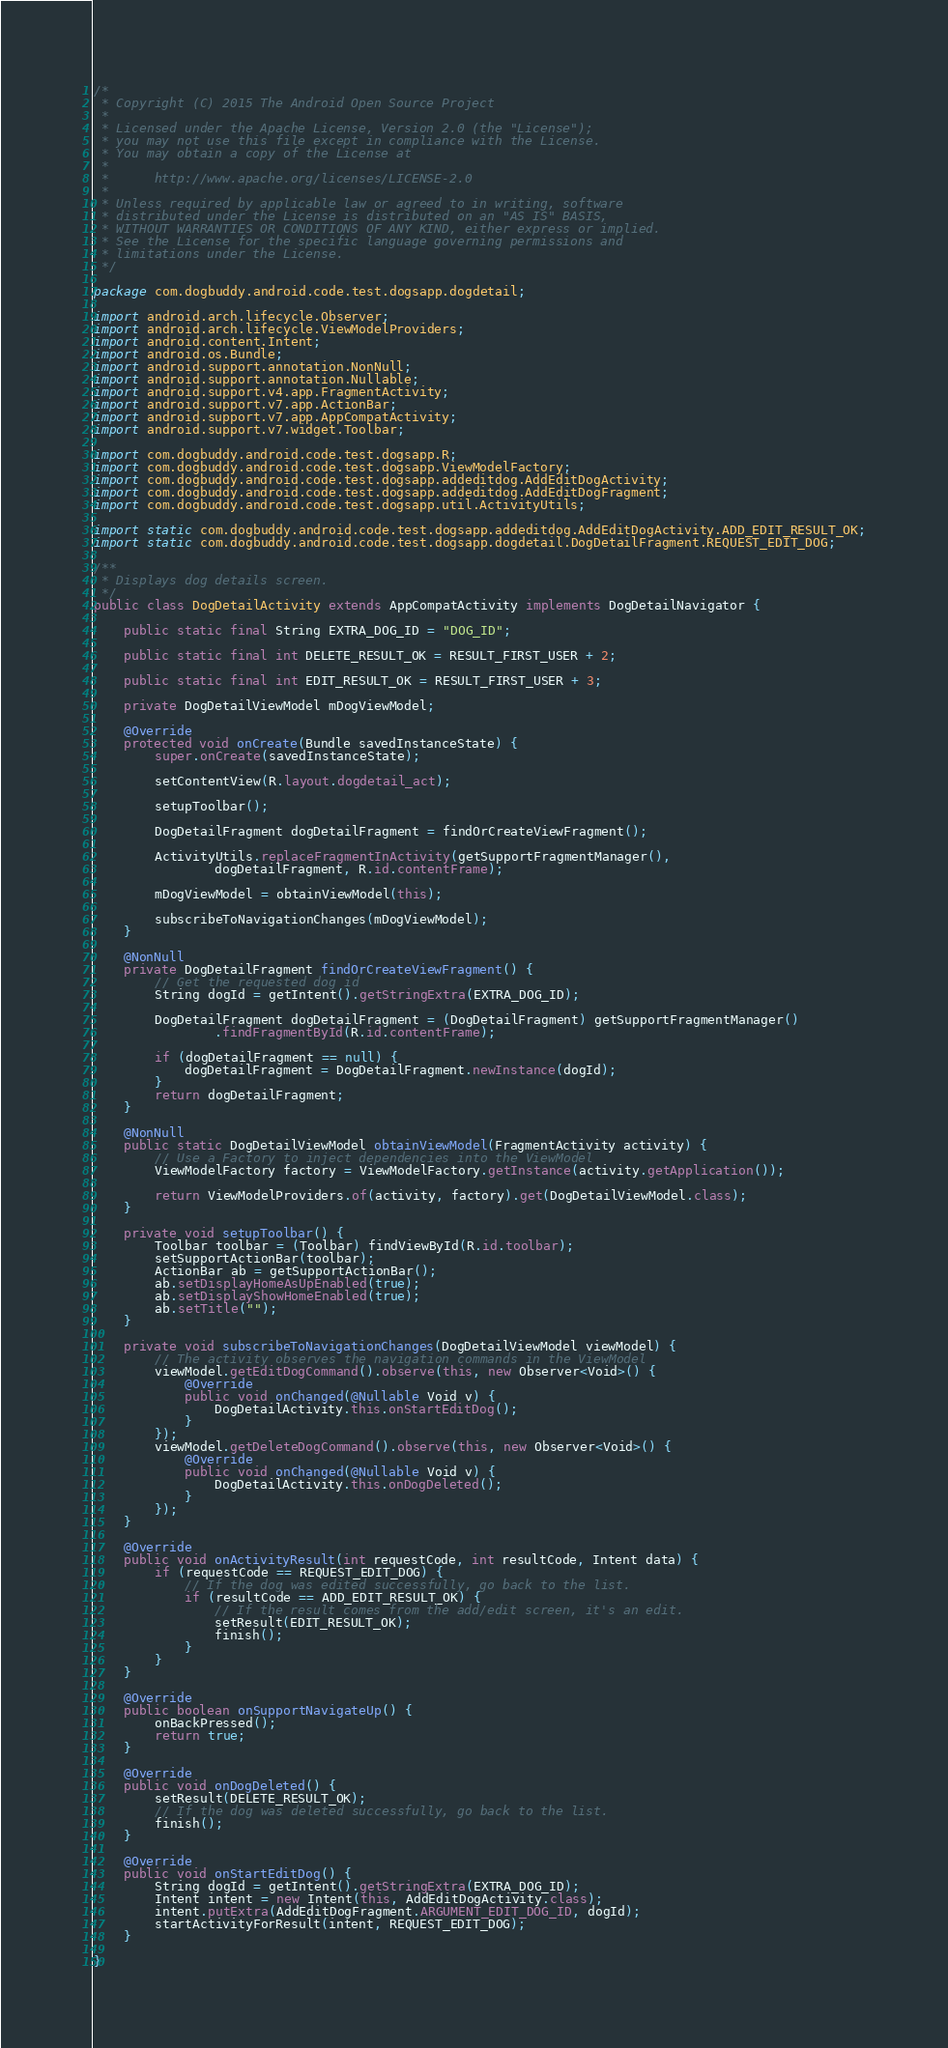<code> <loc_0><loc_0><loc_500><loc_500><_Java_>/*
 * Copyright (C) 2015 The Android Open Source Project
 *
 * Licensed under the Apache License, Version 2.0 (the "License");
 * you may not use this file except in compliance with the License.
 * You may obtain a copy of the License at
 *
 *      http://www.apache.org/licenses/LICENSE-2.0
 *
 * Unless required by applicable law or agreed to in writing, software
 * distributed under the License is distributed on an "AS IS" BASIS,
 * WITHOUT WARRANTIES OR CONDITIONS OF ANY KIND, either express or implied.
 * See the License for the specific language governing permissions and
 * limitations under the License.
 */

package com.dogbuddy.android.code.test.dogsapp.dogdetail;

import android.arch.lifecycle.Observer;
import android.arch.lifecycle.ViewModelProviders;
import android.content.Intent;
import android.os.Bundle;
import android.support.annotation.NonNull;
import android.support.annotation.Nullable;
import android.support.v4.app.FragmentActivity;
import android.support.v7.app.ActionBar;
import android.support.v7.app.AppCompatActivity;
import android.support.v7.widget.Toolbar;

import com.dogbuddy.android.code.test.dogsapp.R;
import com.dogbuddy.android.code.test.dogsapp.ViewModelFactory;
import com.dogbuddy.android.code.test.dogsapp.addeditdog.AddEditDogActivity;
import com.dogbuddy.android.code.test.dogsapp.addeditdog.AddEditDogFragment;
import com.dogbuddy.android.code.test.dogsapp.util.ActivityUtils;

import static com.dogbuddy.android.code.test.dogsapp.addeditdog.AddEditDogActivity.ADD_EDIT_RESULT_OK;
import static com.dogbuddy.android.code.test.dogsapp.dogdetail.DogDetailFragment.REQUEST_EDIT_DOG;

/**
 * Displays dog details screen.
 */
public class DogDetailActivity extends AppCompatActivity implements DogDetailNavigator {

    public static final String EXTRA_DOG_ID = "DOG_ID";

    public static final int DELETE_RESULT_OK = RESULT_FIRST_USER + 2;

    public static final int EDIT_RESULT_OK = RESULT_FIRST_USER + 3;

    private DogDetailViewModel mDogViewModel;

    @Override
    protected void onCreate(Bundle savedInstanceState) {
        super.onCreate(savedInstanceState);

        setContentView(R.layout.dogdetail_act);

        setupToolbar();

        DogDetailFragment dogDetailFragment = findOrCreateViewFragment();

        ActivityUtils.replaceFragmentInActivity(getSupportFragmentManager(),
                dogDetailFragment, R.id.contentFrame);

        mDogViewModel = obtainViewModel(this);

        subscribeToNavigationChanges(mDogViewModel);
    }

    @NonNull
    private DogDetailFragment findOrCreateViewFragment() {
        // Get the requested dog id
        String dogId = getIntent().getStringExtra(EXTRA_DOG_ID);

        DogDetailFragment dogDetailFragment = (DogDetailFragment) getSupportFragmentManager()
                .findFragmentById(R.id.contentFrame);

        if (dogDetailFragment == null) {
            dogDetailFragment = DogDetailFragment.newInstance(dogId);
        }
        return dogDetailFragment;
    }

    @NonNull
    public static DogDetailViewModel obtainViewModel(FragmentActivity activity) {
        // Use a Factory to inject dependencies into the ViewModel
        ViewModelFactory factory = ViewModelFactory.getInstance(activity.getApplication());

        return ViewModelProviders.of(activity, factory).get(DogDetailViewModel.class);
    }

    private void setupToolbar() {
        Toolbar toolbar = (Toolbar) findViewById(R.id.toolbar);
        setSupportActionBar(toolbar);
        ActionBar ab = getSupportActionBar();
        ab.setDisplayHomeAsUpEnabled(true);
        ab.setDisplayShowHomeEnabled(true);
        ab.setTitle("");
    }

    private void subscribeToNavigationChanges(DogDetailViewModel viewModel) {
        // The activity observes the navigation commands in the ViewModel
        viewModel.getEditDogCommand().observe(this, new Observer<Void>() {
            @Override
            public void onChanged(@Nullable Void v) {
                DogDetailActivity.this.onStartEditDog();
            }
        });
        viewModel.getDeleteDogCommand().observe(this, new Observer<Void>() {
            @Override
            public void onChanged(@Nullable Void v) {
                DogDetailActivity.this.onDogDeleted();
            }
        });
    }

    @Override
    public void onActivityResult(int requestCode, int resultCode, Intent data) {
        if (requestCode == REQUEST_EDIT_DOG) {
            // If the dog was edited successfully, go back to the list.
            if (resultCode == ADD_EDIT_RESULT_OK) {
                // If the result comes from the add/edit screen, it's an edit.
                setResult(EDIT_RESULT_OK);
                finish();
            }
        }
    }

    @Override
    public boolean onSupportNavigateUp() {
        onBackPressed();
        return true;
    }

    @Override
    public void onDogDeleted() {
        setResult(DELETE_RESULT_OK);
        // If the dog was deleted successfully, go back to the list.
        finish();
    }

    @Override
    public void onStartEditDog() {
        String dogId = getIntent().getStringExtra(EXTRA_DOG_ID);
        Intent intent = new Intent(this, AddEditDogActivity.class);
        intent.putExtra(AddEditDogFragment.ARGUMENT_EDIT_DOG_ID, dogId);
        startActivityForResult(intent, REQUEST_EDIT_DOG);
    }

}
</code> 